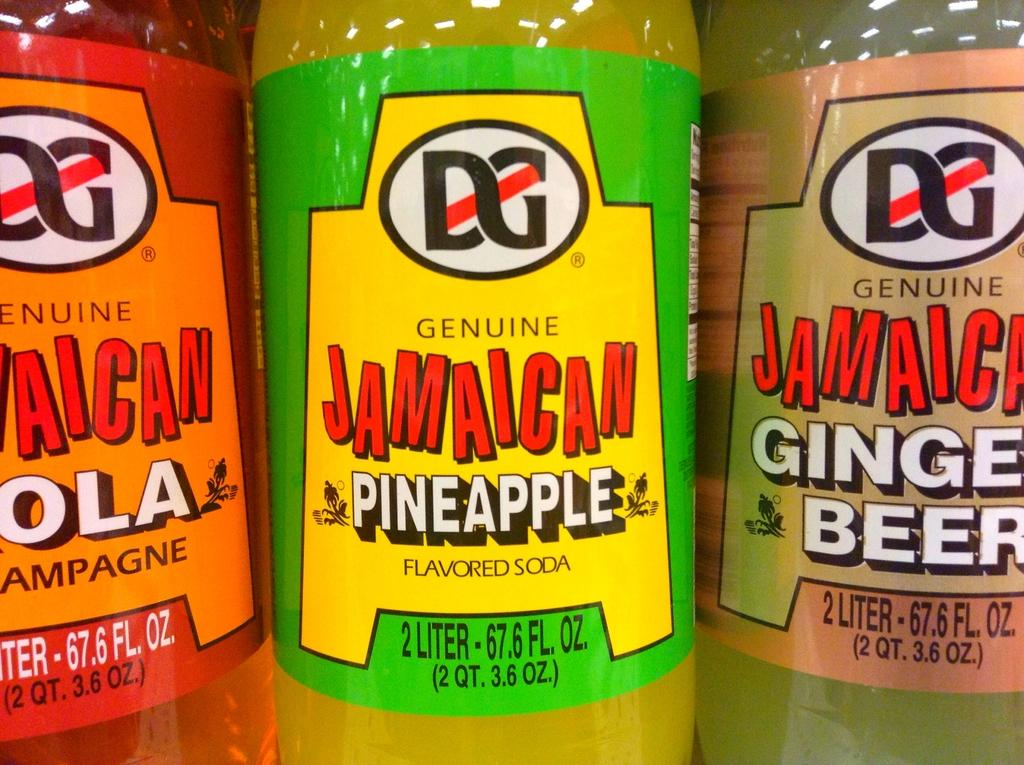<image>
Write a terse but informative summary of the picture. Three bottles of flavored Jamaican soda including Pineapple and Ginger Beer. 